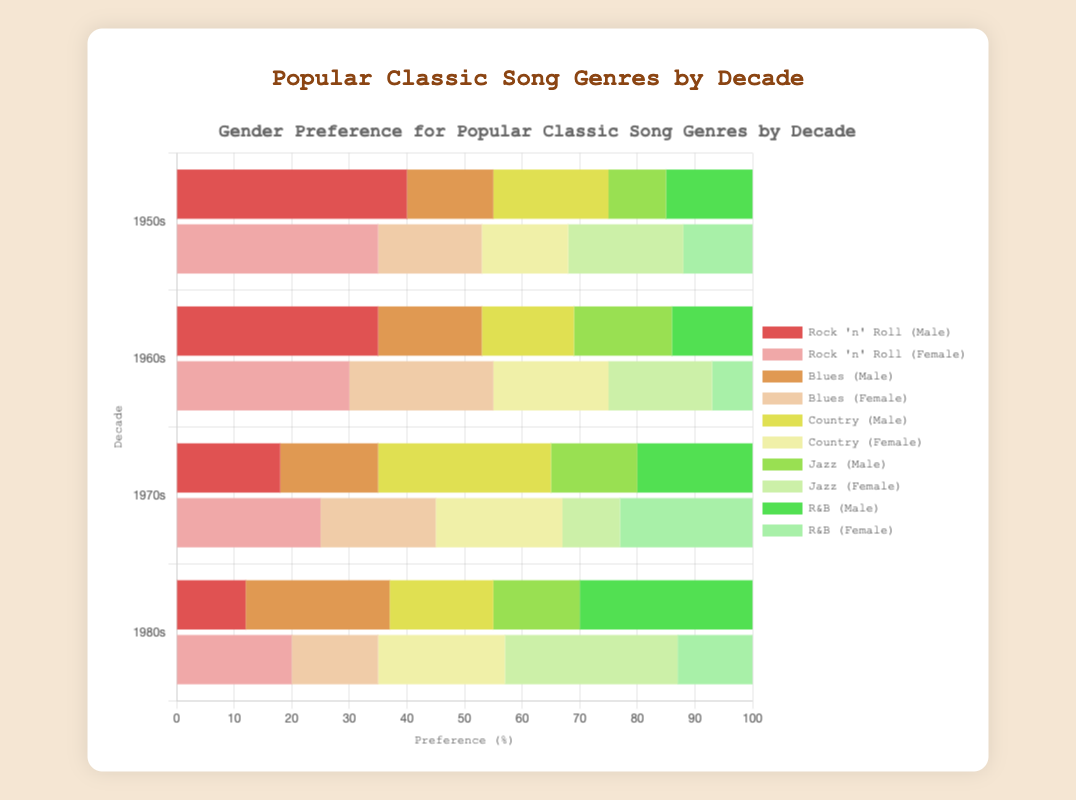What is the most preferred genre by males in the 1950s? Look at the length of the bars labeled for male preference in the 1950s. The longest bar represents Rock 'n' Roll with a preference of 40%.
Answer: Rock 'n' Roll Which genre had the highest female preference in the 1980s? Find the genre in the 1980s with the longest bar for female preference. Pop has the longest bar with a preference of 30%.
Answer: Pop In the 1960s, what is the total combined preference for males and females for the genre with the highest female preference? Identify the genre with the highest female preference in the 1960s, which is Pop at 27%. Add male and female preferences for Pop: 14% + 27% = 41%.
Answer: 41% Which genre has a higher male preference in both the 1970s and 1980s? Compare male preference for all genres listed in both the 1970s and 1980s. Classic Rock in the 1970s (30%) and Rap in the 1980s (30%) both stand out, but they are different genres. However, on consistent comparison across other genres, no other genre appears both in 1970s and 1980s with higher male preference.
Answer: None What is the average female preference for all genres in the 1950s? Calculate the average by summing the female preferences for all genres in the 1950s (35% + 18% + 15% + 20% + 12%) and divide by the number of genres, which is 5. The sum is 100%, so the average is 100% / 5 = 20%.
Answer: 20% Which decade shows a higher preference for Jazz among females? Compare the female preferences for Jazz between the decades. Jazz appears only in the 1950s with a female preference of 20% and not listed in the other decades.
Answer: 1950s What is the difference in male preference between Rock 'n' Roll in the 1950s and Rock in the 1960s? Subtract the male preference for Rock in the 1960s (35%) from Rock 'n' Roll in the 1950s (40%): 40% - 35% = 5%.
Answer: 5% Which genre in the 1970s had a nearly equal preference between males and females? Identify the genres with nearly equal male and female preference in the 1970s. Funk has preferences of 17% (male) and 20% (female), which are relatively close.
Answer: Funk What is the genre with the second-highest male preference in the 1980s? Find the genre with the highest male preference, which is Rap at 30%. Then, identify the genre with the next highest male preference, which is Hair Metal at 25%.
Answer: Hair Metal How does the female preference for New Wave in the 1980s compare to Punk Rock in the 1970s? Look at the female preference for New Wave in the 1980s (22%) and for Punk Rock in the 1970s (10%). Compare the two values: 22% is greater than 10%.
Answer: New Wave has higher preference 